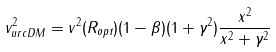Convert formula to latex. <formula><loc_0><loc_0><loc_500><loc_500>v ^ { 2 } _ { u r c D M } = v ^ { 2 } ( R _ { o p t } ) ( 1 - \beta ) ( 1 + \gamma ^ { 2 } ) \frac { x ^ { 2 } } { x ^ { 2 } + \gamma ^ { 2 } }</formula> 